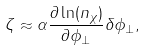<formula> <loc_0><loc_0><loc_500><loc_500>\zeta \approx \alpha \frac { \partial \ln ( n _ { \chi } ) } { \partial \phi _ { \perp } } \delta \phi _ { \perp } ,</formula> 